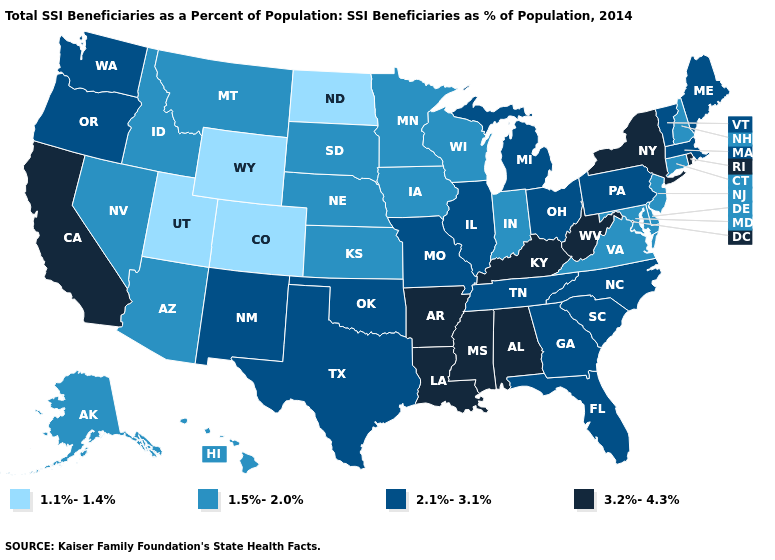Does Maryland have a lower value than Mississippi?
Quick response, please. Yes. Name the states that have a value in the range 1.1%-1.4%?
Keep it brief. Colorado, North Dakota, Utah, Wyoming. Among the states that border Louisiana , which have the highest value?
Be succinct. Arkansas, Mississippi. Among the states that border Michigan , which have the highest value?
Short answer required. Ohio. Name the states that have a value in the range 2.1%-3.1%?
Be succinct. Florida, Georgia, Illinois, Maine, Massachusetts, Michigan, Missouri, New Mexico, North Carolina, Ohio, Oklahoma, Oregon, Pennsylvania, South Carolina, Tennessee, Texas, Vermont, Washington. Does Utah have the same value as Connecticut?
Keep it brief. No. Name the states that have a value in the range 2.1%-3.1%?
Give a very brief answer. Florida, Georgia, Illinois, Maine, Massachusetts, Michigan, Missouri, New Mexico, North Carolina, Ohio, Oklahoma, Oregon, Pennsylvania, South Carolina, Tennessee, Texas, Vermont, Washington. Among the states that border Pennsylvania , does New York have the highest value?
Give a very brief answer. Yes. What is the value of West Virginia?
Give a very brief answer. 3.2%-4.3%. Name the states that have a value in the range 1.5%-2.0%?
Give a very brief answer. Alaska, Arizona, Connecticut, Delaware, Hawaii, Idaho, Indiana, Iowa, Kansas, Maryland, Minnesota, Montana, Nebraska, Nevada, New Hampshire, New Jersey, South Dakota, Virginia, Wisconsin. Name the states that have a value in the range 1.1%-1.4%?
Keep it brief. Colorado, North Dakota, Utah, Wyoming. Name the states that have a value in the range 1.5%-2.0%?
Write a very short answer. Alaska, Arizona, Connecticut, Delaware, Hawaii, Idaho, Indiana, Iowa, Kansas, Maryland, Minnesota, Montana, Nebraska, Nevada, New Hampshire, New Jersey, South Dakota, Virginia, Wisconsin. Name the states that have a value in the range 1.5%-2.0%?
Give a very brief answer. Alaska, Arizona, Connecticut, Delaware, Hawaii, Idaho, Indiana, Iowa, Kansas, Maryland, Minnesota, Montana, Nebraska, Nevada, New Hampshire, New Jersey, South Dakota, Virginia, Wisconsin. Does Missouri have the highest value in the USA?
Keep it brief. No. What is the value of Georgia?
Concise answer only. 2.1%-3.1%. 